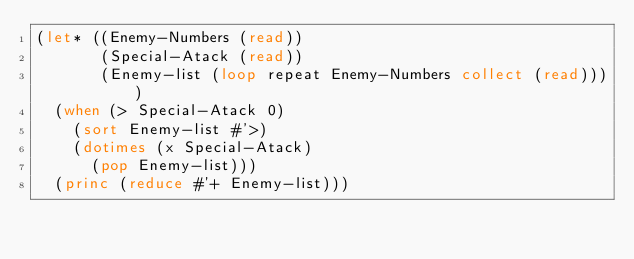Convert code to text. <code><loc_0><loc_0><loc_500><loc_500><_Lisp_>(let* ((Enemy-Numbers (read))
       (Special-Atack (read))
       (Enemy-list (loop repeat Enemy-Numbers collect (read))))
  (when (> Special-Atack 0)
    (sort Enemy-list #'>)
    (dotimes (x Special-Atack)
      (pop Enemy-list)))
  (princ (reduce #'+ Enemy-list)))
</code> 